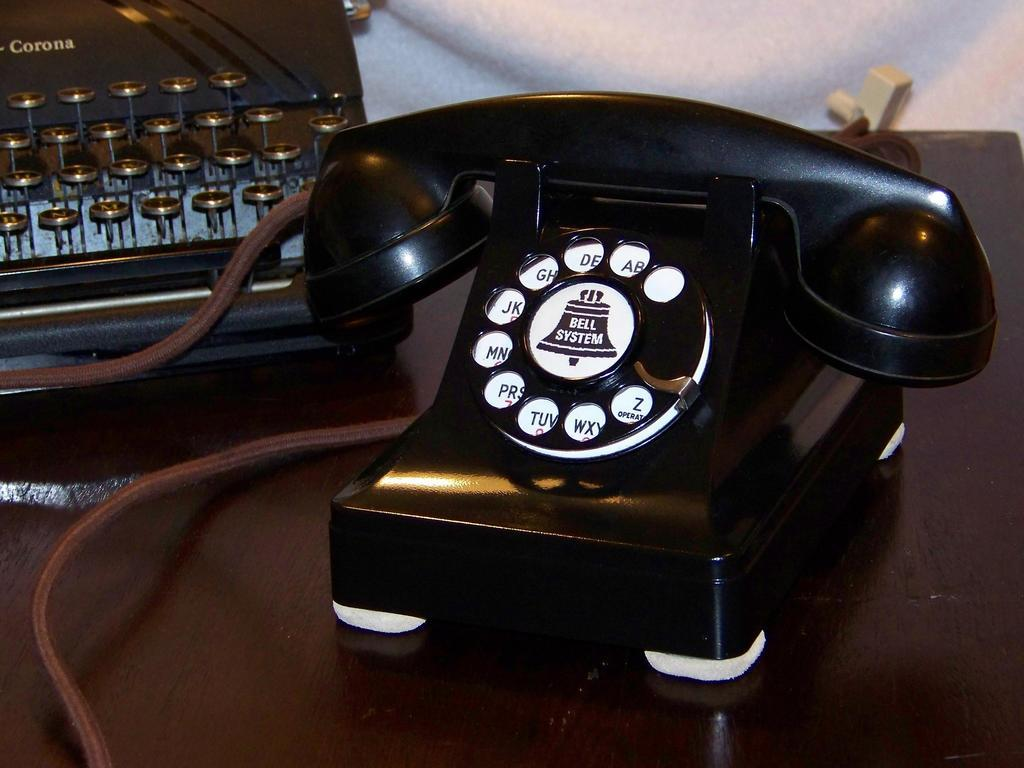What object can be seen in the image that is used for communication? There is a telephone in the image that is used for communication. Where is the telephone placed in the image? The telephone is placed on a table in the image. What is connected to the telephone in the image? There is a brown wire attached to the telephone in the image. What other objects can be seen in the background of the image? There is a typewriter and a cloth in the background of the image. What type of clover is growing on the telephone wire in the image? There is no clover present in the image, and the wire is not depicted as a place where plants would grow. 